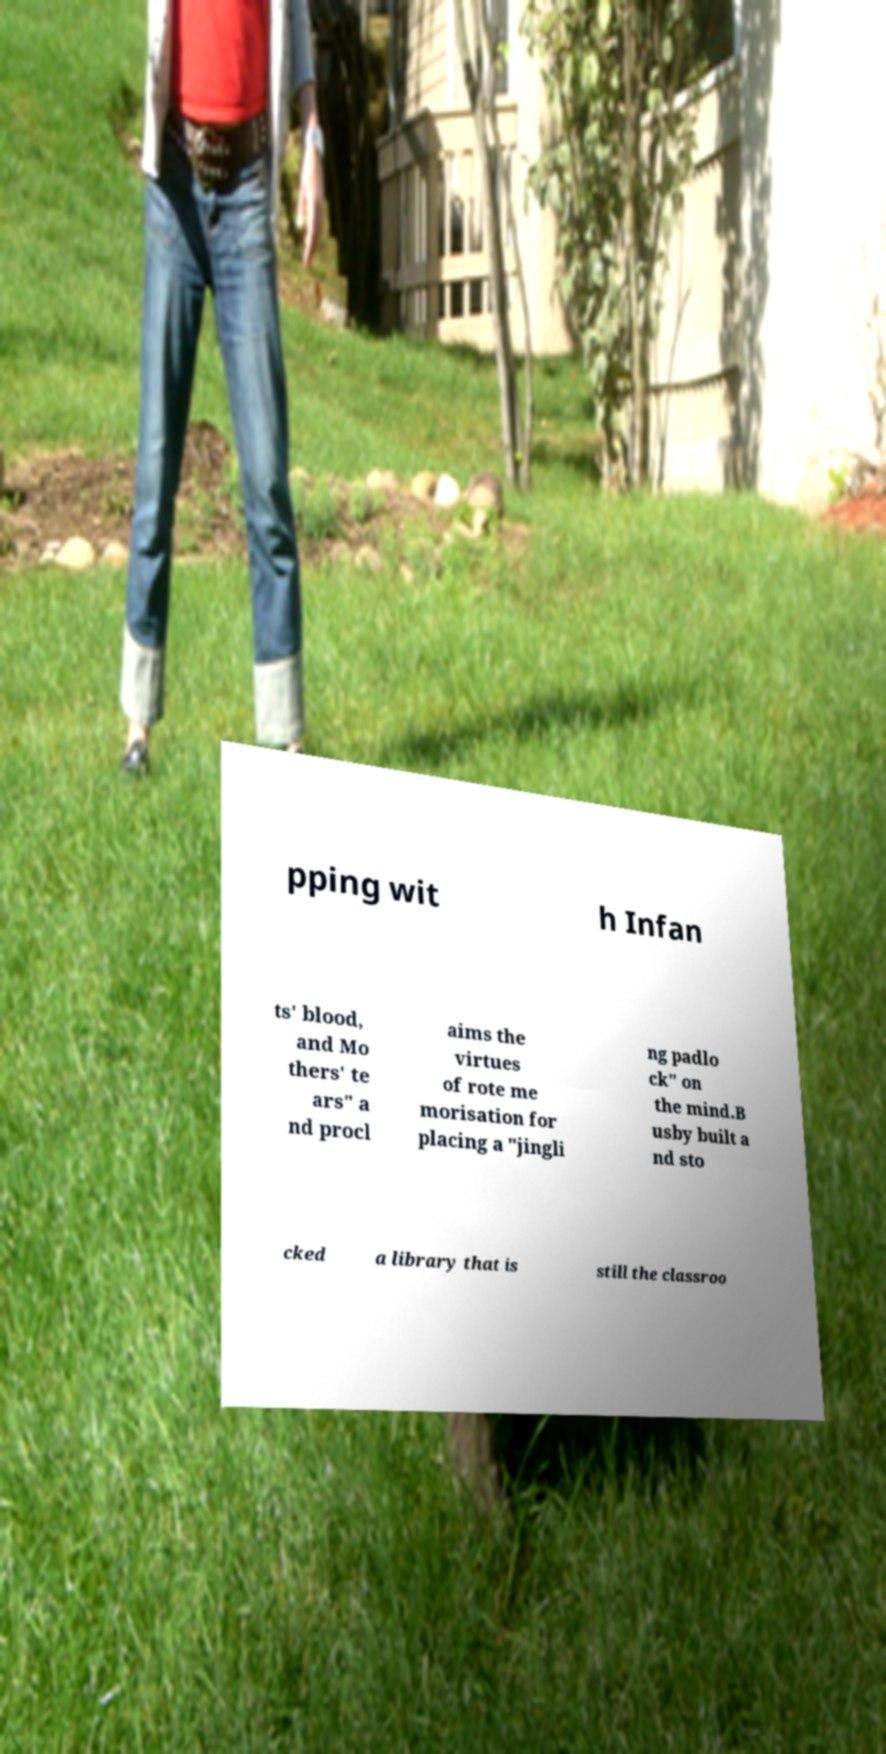Please identify and transcribe the text found in this image. pping wit h Infan ts' blood, and Mo thers' te ars" a nd procl aims the virtues of rote me morisation for placing a "jingli ng padlo ck" on the mind.B usby built a nd sto cked a library that is still the classroo 